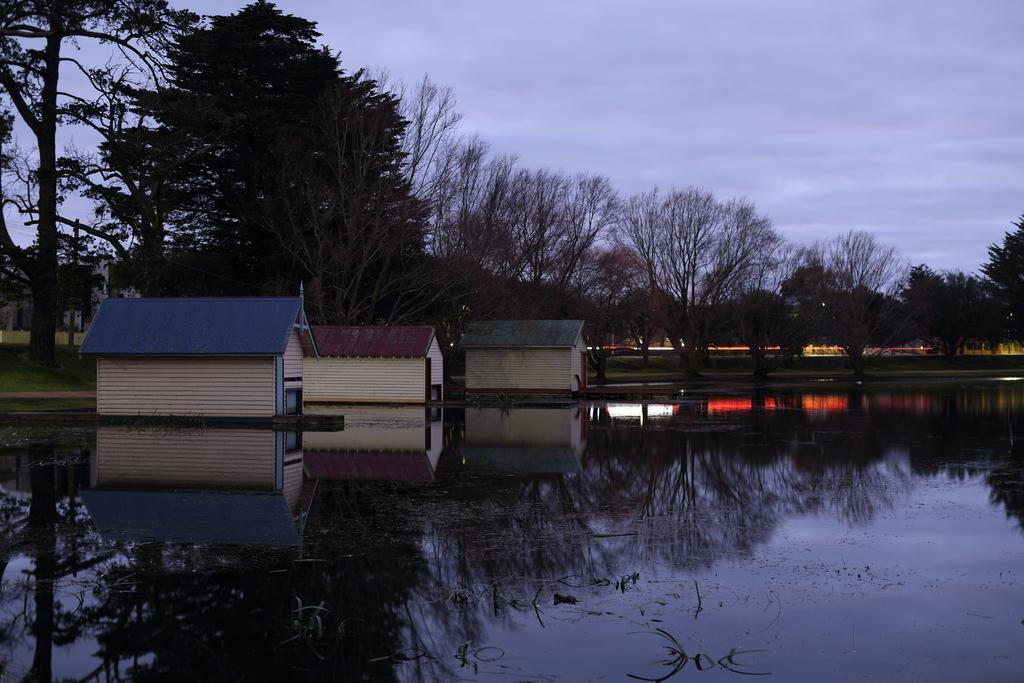Can you describe this image briefly? In this image I can see the water. To the side I can see the house. In the background I can see many trees and the sky. 